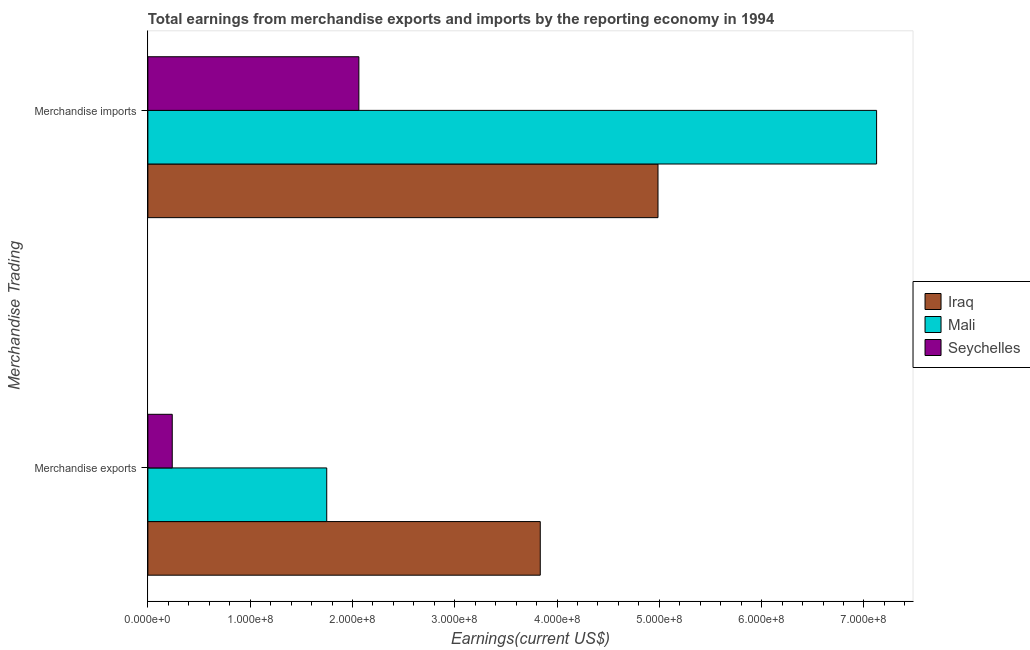How many different coloured bars are there?
Provide a short and direct response. 3. Are the number of bars per tick equal to the number of legend labels?
Your answer should be very brief. Yes. How many bars are there on the 2nd tick from the top?
Make the answer very short. 3. How many bars are there on the 1st tick from the bottom?
Ensure brevity in your answer.  3. What is the earnings from merchandise exports in Mali?
Ensure brevity in your answer.  1.75e+08. Across all countries, what is the maximum earnings from merchandise exports?
Give a very brief answer. 3.84e+08. Across all countries, what is the minimum earnings from merchandise imports?
Offer a terse response. 2.06e+08. In which country was the earnings from merchandise imports maximum?
Provide a short and direct response. Mali. In which country was the earnings from merchandise exports minimum?
Your answer should be very brief. Seychelles. What is the total earnings from merchandise imports in the graph?
Your answer should be very brief. 1.42e+09. What is the difference between the earnings from merchandise imports in Seychelles and that in Iraq?
Your answer should be compact. -2.92e+08. What is the difference between the earnings from merchandise exports in Iraq and the earnings from merchandise imports in Seychelles?
Provide a succinct answer. 1.77e+08. What is the average earnings from merchandise exports per country?
Ensure brevity in your answer.  1.94e+08. What is the difference between the earnings from merchandise exports and earnings from merchandise imports in Mali?
Your response must be concise. -5.37e+08. In how many countries, is the earnings from merchandise imports greater than 220000000 US$?
Make the answer very short. 2. What is the ratio of the earnings from merchandise exports in Mali to that in Seychelles?
Give a very brief answer. 7.34. In how many countries, is the earnings from merchandise imports greater than the average earnings from merchandise imports taken over all countries?
Provide a short and direct response. 2. What does the 3rd bar from the top in Merchandise imports represents?
Offer a very short reply. Iraq. What does the 1st bar from the bottom in Merchandise exports represents?
Provide a succinct answer. Iraq. Are all the bars in the graph horizontal?
Provide a short and direct response. Yes. What is the difference between two consecutive major ticks on the X-axis?
Offer a very short reply. 1.00e+08. Does the graph contain any zero values?
Your answer should be compact. No. How many legend labels are there?
Offer a very short reply. 3. How are the legend labels stacked?
Provide a succinct answer. Vertical. What is the title of the graph?
Provide a succinct answer. Total earnings from merchandise exports and imports by the reporting economy in 1994. What is the label or title of the X-axis?
Give a very brief answer. Earnings(current US$). What is the label or title of the Y-axis?
Offer a very short reply. Merchandise Trading. What is the Earnings(current US$) in Iraq in Merchandise exports?
Ensure brevity in your answer.  3.84e+08. What is the Earnings(current US$) in Mali in Merchandise exports?
Offer a terse response. 1.75e+08. What is the Earnings(current US$) of Seychelles in Merchandise exports?
Offer a terse response. 2.38e+07. What is the Earnings(current US$) of Iraq in Merchandise imports?
Give a very brief answer. 4.99e+08. What is the Earnings(current US$) of Mali in Merchandise imports?
Ensure brevity in your answer.  7.12e+08. What is the Earnings(current US$) in Seychelles in Merchandise imports?
Your answer should be very brief. 2.06e+08. Across all Merchandise Trading, what is the maximum Earnings(current US$) of Iraq?
Provide a succinct answer. 4.99e+08. Across all Merchandise Trading, what is the maximum Earnings(current US$) of Mali?
Offer a very short reply. 7.12e+08. Across all Merchandise Trading, what is the maximum Earnings(current US$) in Seychelles?
Ensure brevity in your answer.  2.06e+08. Across all Merchandise Trading, what is the minimum Earnings(current US$) in Iraq?
Provide a succinct answer. 3.84e+08. Across all Merchandise Trading, what is the minimum Earnings(current US$) in Mali?
Make the answer very short. 1.75e+08. Across all Merchandise Trading, what is the minimum Earnings(current US$) of Seychelles?
Make the answer very short. 2.38e+07. What is the total Earnings(current US$) in Iraq in the graph?
Give a very brief answer. 8.82e+08. What is the total Earnings(current US$) of Mali in the graph?
Offer a terse response. 8.87e+08. What is the total Earnings(current US$) in Seychelles in the graph?
Offer a very short reply. 2.30e+08. What is the difference between the Earnings(current US$) in Iraq in Merchandise exports and that in Merchandise imports?
Provide a succinct answer. -1.15e+08. What is the difference between the Earnings(current US$) in Mali in Merchandise exports and that in Merchandise imports?
Make the answer very short. -5.37e+08. What is the difference between the Earnings(current US$) in Seychelles in Merchandise exports and that in Merchandise imports?
Your answer should be compact. -1.82e+08. What is the difference between the Earnings(current US$) in Iraq in Merchandise exports and the Earnings(current US$) in Mali in Merchandise imports?
Offer a very short reply. -3.29e+08. What is the difference between the Earnings(current US$) in Iraq in Merchandise exports and the Earnings(current US$) in Seychelles in Merchandise imports?
Make the answer very short. 1.77e+08. What is the difference between the Earnings(current US$) in Mali in Merchandise exports and the Earnings(current US$) in Seychelles in Merchandise imports?
Provide a succinct answer. -3.14e+07. What is the average Earnings(current US$) of Iraq per Merchandise Trading?
Your response must be concise. 4.41e+08. What is the average Earnings(current US$) in Mali per Merchandise Trading?
Your answer should be compact. 4.44e+08. What is the average Earnings(current US$) of Seychelles per Merchandise Trading?
Keep it short and to the point. 1.15e+08. What is the difference between the Earnings(current US$) in Iraq and Earnings(current US$) in Mali in Merchandise exports?
Ensure brevity in your answer.  2.09e+08. What is the difference between the Earnings(current US$) in Iraq and Earnings(current US$) in Seychelles in Merchandise exports?
Your answer should be compact. 3.60e+08. What is the difference between the Earnings(current US$) of Mali and Earnings(current US$) of Seychelles in Merchandise exports?
Your answer should be compact. 1.51e+08. What is the difference between the Earnings(current US$) of Iraq and Earnings(current US$) of Mali in Merchandise imports?
Keep it short and to the point. -2.14e+08. What is the difference between the Earnings(current US$) of Iraq and Earnings(current US$) of Seychelles in Merchandise imports?
Offer a terse response. 2.92e+08. What is the difference between the Earnings(current US$) in Mali and Earnings(current US$) in Seychelles in Merchandise imports?
Provide a succinct answer. 5.06e+08. What is the ratio of the Earnings(current US$) of Iraq in Merchandise exports to that in Merchandise imports?
Your answer should be very brief. 0.77. What is the ratio of the Earnings(current US$) in Mali in Merchandise exports to that in Merchandise imports?
Your answer should be very brief. 0.25. What is the ratio of the Earnings(current US$) in Seychelles in Merchandise exports to that in Merchandise imports?
Your answer should be compact. 0.12. What is the difference between the highest and the second highest Earnings(current US$) of Iraq?
Keep it short and to the point. 1.15e+08. What is the difference between the highest and the second highest Earnings(current US$) in Mali?
Provide a short and direct response. 5.37e+08. What is the difference between the highest and the second highest Earnings(current US$) in Seychelles?
Offer a very short reply. 1.82e+08. What is the difference between the highest and the lowest Earnings(current US$) in Iraq?
Your answer should be compact. 1.15e+08. What is the difference between the highest and the lowest Earnings(current US$) in Mali?
Ensure brevity in your answer.  5.37e+08. What is the difference between the highest and the lowest Earnings(current US$) of Seychelles?
Your answer should be very brief. 1.82e+08. 